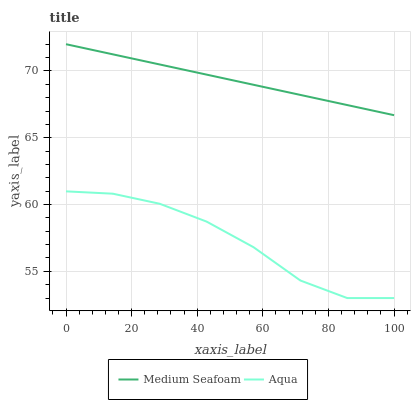Does Aqua have the minimum area under the curve?
Answer yes or no. Yes. Does Medium Seafoam have the maximum area under the curve?
Answer yes or no. Yes. Does Medium Seafoam have the minimum area under the curve?
Answer yes or no. No. Is Medium Seafoam the smoothest?
Answer yes or no. Yes. Is Aqua the roughest?
Answer yes or no. Yes. Is Medium Seafoam the roughest?
Answer yes or no. No. Does Aqua have the lowest value?
Answer yes or no. Yes. Does Medium Seafoam have the lowest value?
Answer yes or no. No. Does Medium Seafoam have the highest value?
Answer yes or no. Yes. Is Aqua less than Medium Seafoam?
Answer yes or no. Yes. Is Medium Seafoam greater than Aqua?
Answer yes or no. Yes. Does Aqua intersect Medium Seafoam?
Answer yes or no. No. 